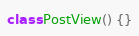Convert code to text. <code><loc_0><loc_0><loc_500><loc_500><_Ceylon_>class PostView() {}</code> 